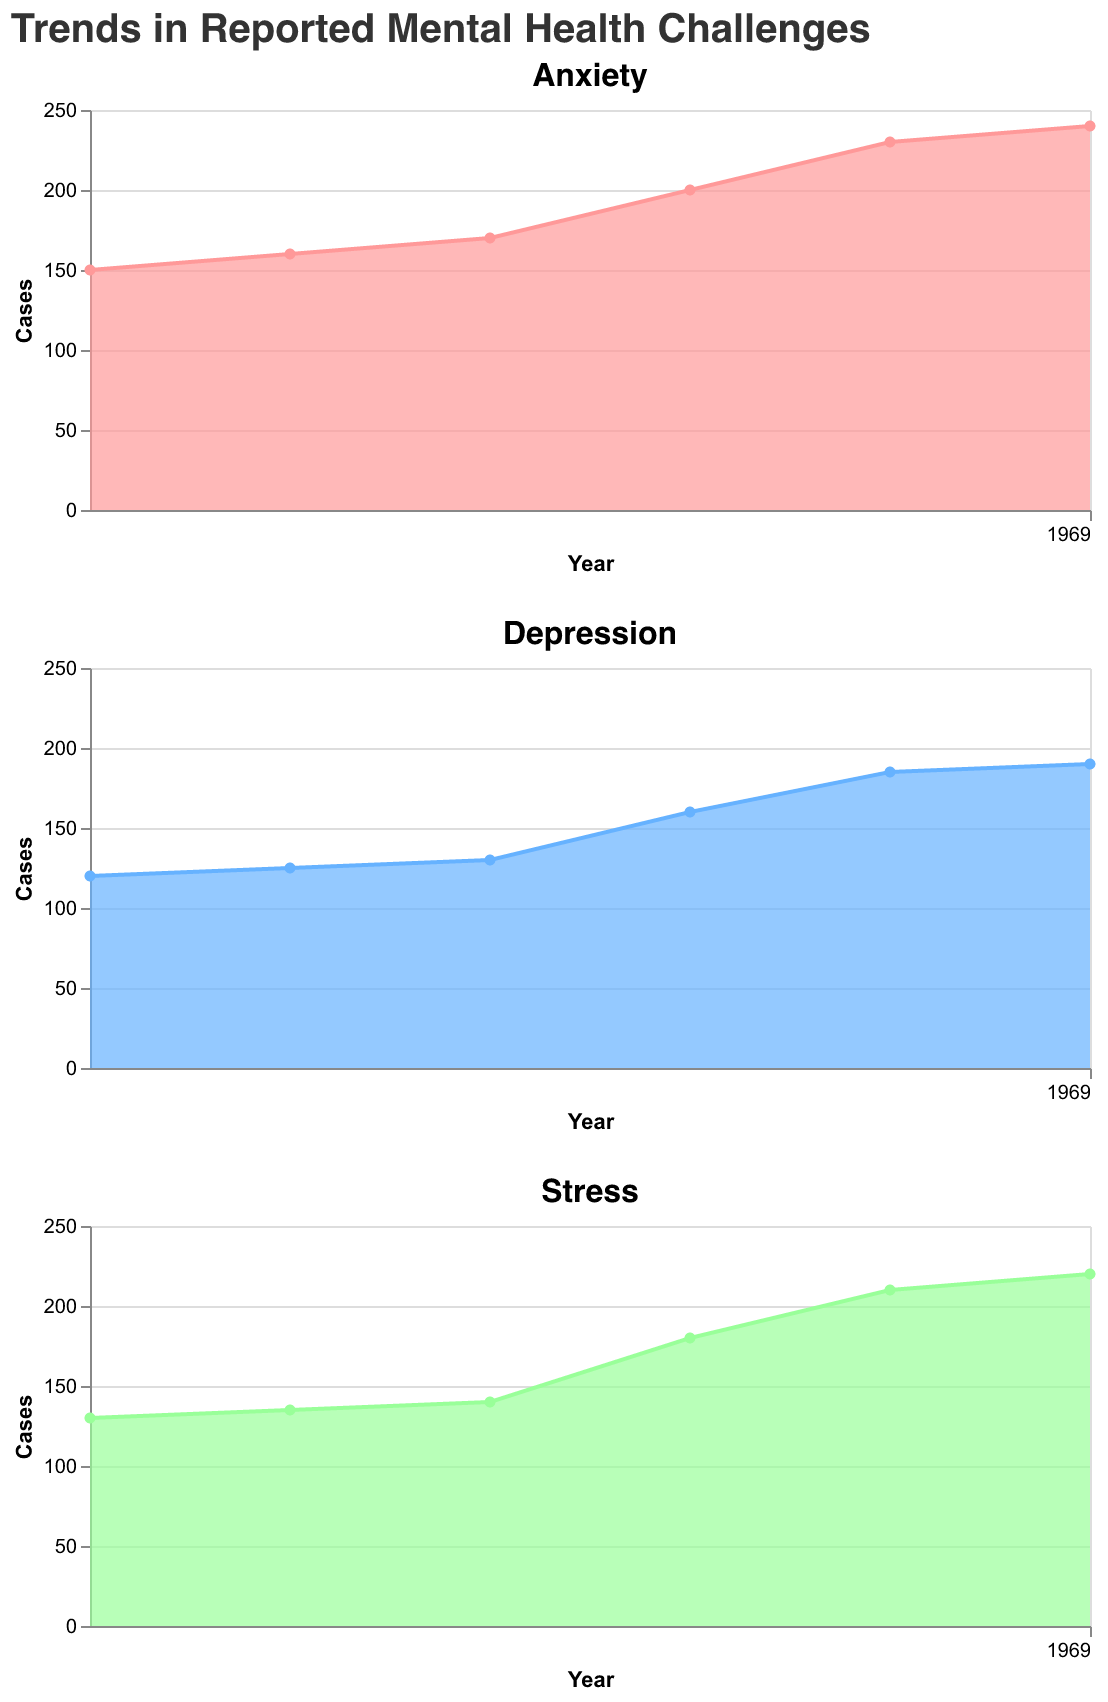What is the title of the figure? The title is displayed at the top of the figure and reads "Trends in Reported Mental Health Challenges".
Answer: Trends in Reported Mental Health Challenges Which category had the highest number of reported cases in 2022? The figure shows the trends of Anxiety, Depression, and Stress. For 2022, the Anxiety plot reaches the highest point, indicating it had the highest number of reported cases.
Answer: Anxiety How do the counts of Depression in 2019 and 2020 compare? Looking at the Depression subplot, the data points for 2019 and 2020 show that the count increases from 130 in 2019 to 160 in 2020.
Answer: The count increases What is the difference in Stress cases between 2017 and 2022? The figure shows Stress cases at approximately 130 in 2017 and 220 in 2022. The difference is calculated as 220 - 130.
Answer: 90 Which category showed the steepest increase between 2019 and 2020? Observe the slope of the lines in the subplots. Anxiety shows the biggest jump from 170 to 200 between 2019 and 2020.
Answer: Anxiety In which year did Anxiety cases first exceed 200? By examining the Anxiety subplot, cases exceed 200 in 2021.
Answer: 2021 Between which two consecutive years is the largest increase in Depression cases observed? Check the changes in Depression cases year over year; the largest increase is from 2020 to 2021, going from 160 to 185.
Answer: 2020 to 2021 What are the colors used for each mental health category? Anxiety uses a pinkish-red color, Depression uses a blue color, and Stress uses a green color.
Answer: Pinkish-red (Anxiety), Blue (Depression), Green (Stress) What is the overall trend observed for Stress cases from 2017 to 2022? Each year, the figure shows an upward trend in Stress cases, increasing steadily from 130 in 2017 to 220 in 2022.
Answer: Increasing Calculate the average number of Depression cases from 2017 to 2022. Add the cases for each year: 120 (2017) + 125 (2018) + 130 (2019) + 160 (2020) + 185 (2021) + 190 (2022) = 910. Divide by the number of years, 910/6.
Answer: 151.67 